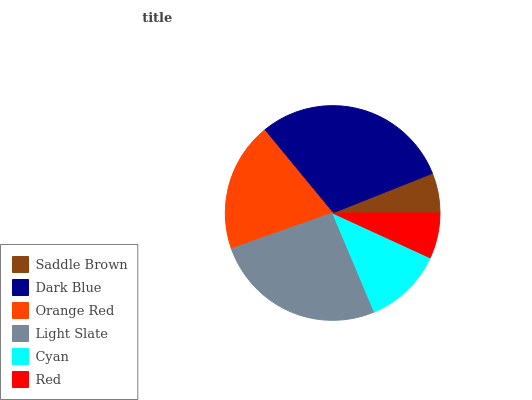Is Saddle Brown the minimum?
Answer yes or no. Yes. Is Dark Blue the maximum?
Answer yes or no. Yes. Is Orange Red the minimum?
Answer yes or no. No. Is Orange Red the maximum?
Answer yes or no. No. Is Dark Blue greater than Orange Red?
Answer yes or no. Yes. Is Orange Red less than Dark Blue?
Answer yes or no. Yes. Is Orange Red greater than Dark Blue?
Answer yes or no. No. Is Dark Blue less than Orange Red?
Answer yes or no. No. Is Orange Red the high median?
Answer yes or no. Yes. Is Cyan the low median?
Answer yes or no. Yes. Is Red the high median?
Answer yes or no. No. Is Orange Red the low median?
Answer yes or no. No. 